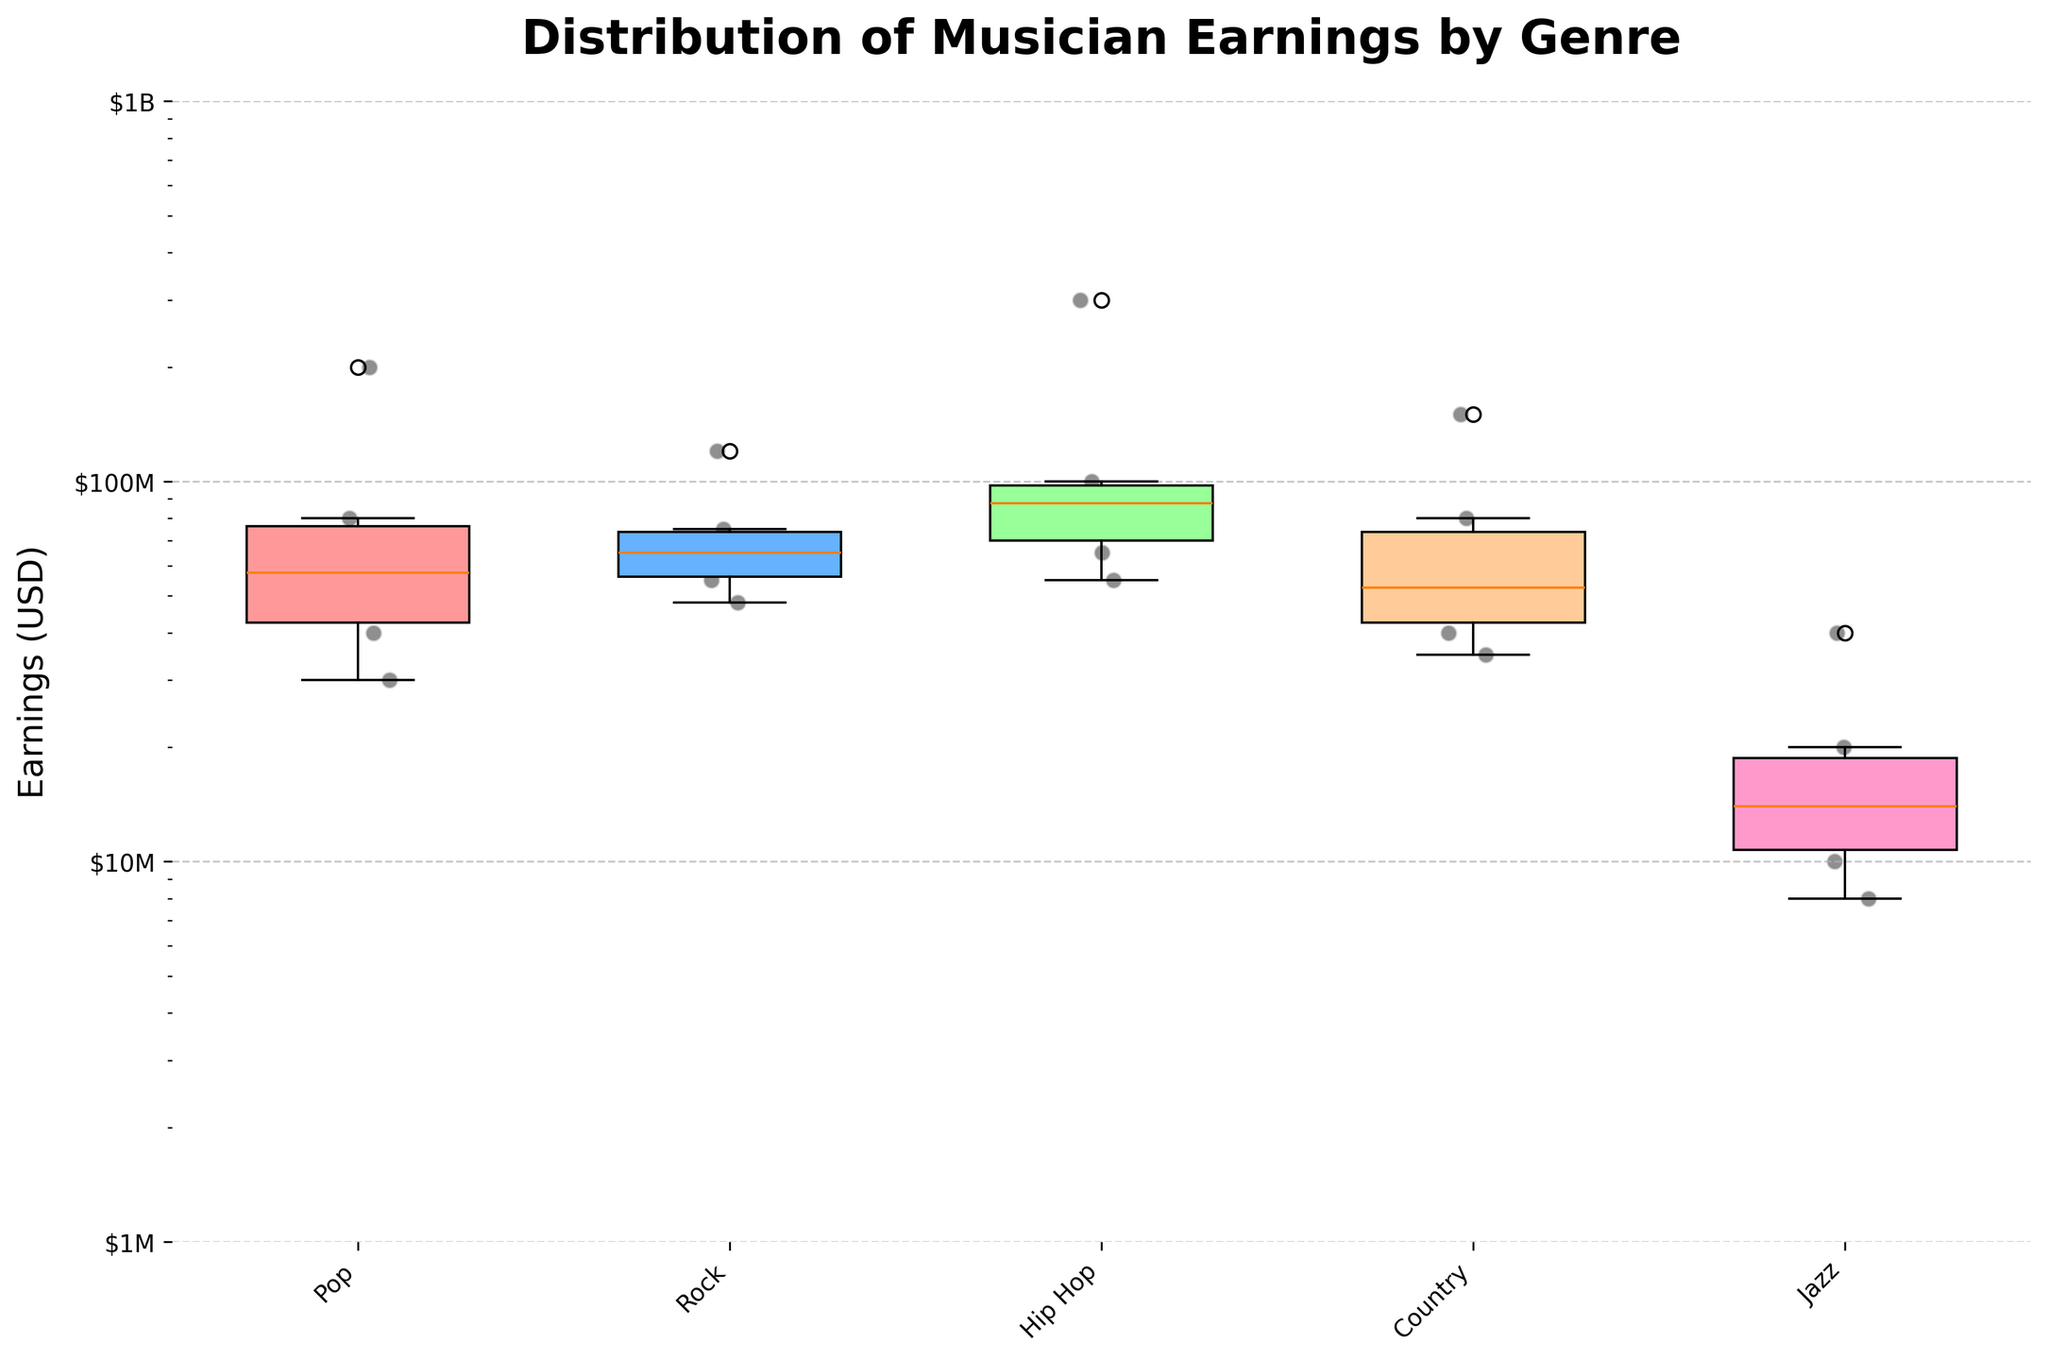How many different genres are represented in the plot? By looking at the x-axis labels, you can count the different genres shown. Each genre label corresponds to a box plot on the figure.
Answer: 5 Which genre has the highest median earnings? The median earnings for each genre are represented by the horizontal line inside each box. By identifying which box plot has the highest median line, you can determine the genre with the highest median earnings.
Answer: Hip Hop Which genre has the widest range of musician earnings? The range of earnings for each genre is represented by the length of the whiskers (vertical lines) on each box plot. The genre with the longest whiskers has the widest range of earnings.
Answer: Hip Hop What is the earnings range for Jazz musicians, excluding outliers? The earnings range is given by the distance between the bottom and top whiskers of the Jazz box plot. By locating the endpoints of these whiskers, you can calculate the range.
Answer: $8M–$20M Which genre has the largest outlier earnings, and what is its value? The outliers are represented by scatter points that fall outside the whiskers. By identifying the outlier scatter point with the highest value, you can find the genre and value.
Answer: Hip Hop, $300M How do the median earnings of Pop and Rock genres compare? To compare the medians, observe the horizontal lines inside the box plots for Pop and Rock and determine which is higher.
Answer: Pop is higher What percentage of Hip Hop musicians listed are outliers? First, count the total number of Hip Hop musicians in the figure. Then, count the number of outliers in the Hip Hop genre. Use these counts to calculate the percentage of outliers.
Answer: 16.7% (1 outlier out of 6 musicians) What is the interquartile range (IQR) for Country musicians? The IQR is the range between the first quartile (bottom of the box) and the third quartile (top of the box). Locate these points in the Country box plot to calculate the IQR.
Answer: $40M–$80M 